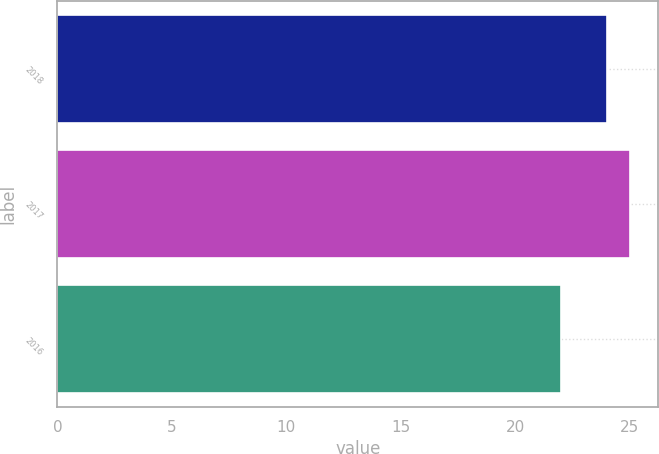<chart> <loc_0><loc_0><loc_500><loc_500><bar_chart><fcel>2018<fcel>2017<fcel>2016<nl><fcel>24<fcel>25<fcel>22<nl></chart> 